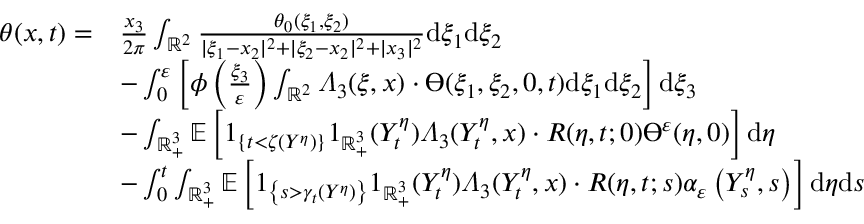Convert formula to latex. <formula><loc_0><loc_0><loc_500><loc_500>\begin{array} { r l } { \theta ( x , t ) = } & { \frac { x _ { 3 } } { 2 \pi } \int _ { \mathbb { R } ^ { 2 } } \frac { \theta _ { 0 } ( \xi _ { 1 } , \xi _ { 2 } ) } { | \xi _ { 1 } - x _ { 2 } | ^ { 2 } + | \xi _ { 2 } - x _ { 2 } | ^ { 2 } + | x _ { 3 } | ^ { 2 } } d \xi _ { 1 } d \xi _ { 2 } } \\ & { - \int _ { 0 } ^ { \varepsilon } \left [ \phi \left ( \frac { \xi _ { 3 } } { \varepsilon } \right ) \int _ { \mathbb { R } ^ { 2 } } \varLambda _ { 3 } ( \xi , x ) \cdot \varTheta ( \xi _ { 1 } , \xi _ { 2 } , 0 , t ) d \xi _ { 1 } d \xi _ { 2 } \right ] d \xi _ { 3 } } \\ & { - \int _ { \mathbb { R } _ { + } ^ { 3 } } \mathbb { E } \left [ 1 _ { \{ t < \zeta ( Y ^ { \eta } ) \} } 1 _ { \mathbb { R } _ { + } ^ { 3 } } ( Y _ { t } ^ { \eta } ) \varLambda _ { 3 } ( Y _ { t } ^ { \eta } , x ) \cdot R ( \eta , t ; 0 ) \varTheta ^ { \varepsilon } ( \eta , 0 ) \right ] d \eta } \\ & { - \int _ { 0 } ^ { t } \int _ { \mathbb { R } _ { + } ^ { 3 } } \mathbb { E } \left [ 1 _ { \left \{ s > \gamma _ { t } ( Y ^ { \eta } ) \right \} } 1 _ { \mathbb { R } _ { + } ^ { 3 } } ( Y _ { t } ^ { \eta } ) \varLambda _ { 3 } ( Y _ { t } ^ { \eta } , x ) \cdot R ( \eta , t ; s ) \alpha _ { \varepsilon } \left ( Y _ { s } ^ { \eta } , s \right ) \right ] d \eta d s } \end{array}</formula> 